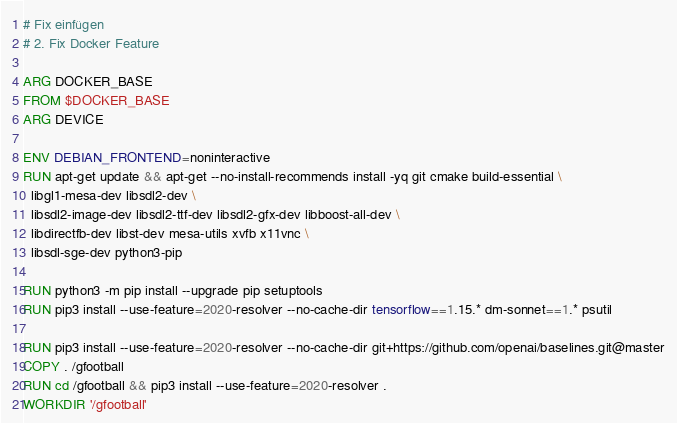<code> <loc_0><loc_0><loc_500><loc_500><_Dockerfile_># Fix einfügen
# 2. Fix Docker Feature

ARG DOCKER_BASE
FROM $DOCKER_BASE
ARG DEVICE

ENV DEBIAN_FRONTEND=noninteractive
RUN apt-get update && apt-get --no-install-recommends install -yq git cmake build-essential \
  libgl1-mesa-dev libsdl2-dev \
  libsdl2-image-dev libsdl2-ttf-dev libsdl2-gfx-dev libboost-all-dev \
  libdirectfb-dev libst-dev mesa-utils xvfb x11vnc \
  libsdl-sge-dev python3-pip

RUN python3 -m pip install --upgrade pip setuptools
RUN pip3 install --use-feature=2020-resolver --no-cache-dir tensorflow==1.15.* dm-sonnet==1.* psutil

RUN pip3 install --use-feature=2020-resolver --no-cache-dir git+https://github.com/openai/baselines.git@master
COPY . /gfootball
RUN cd /gfootball && pip3 install --use-feature=2020-resolver .
WORKDIR '/gfootball'
</code> 